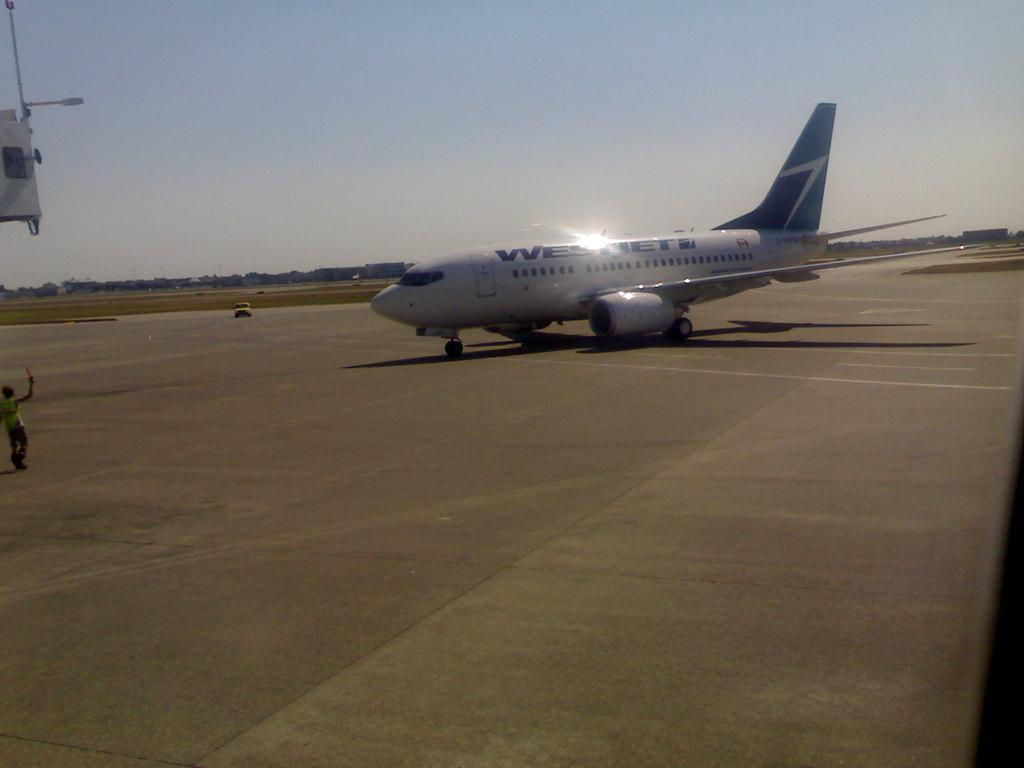<image>
Render a clear and concise summary of the photo. A commercial passenger jet that says WestJet is taxiing on a runway. 